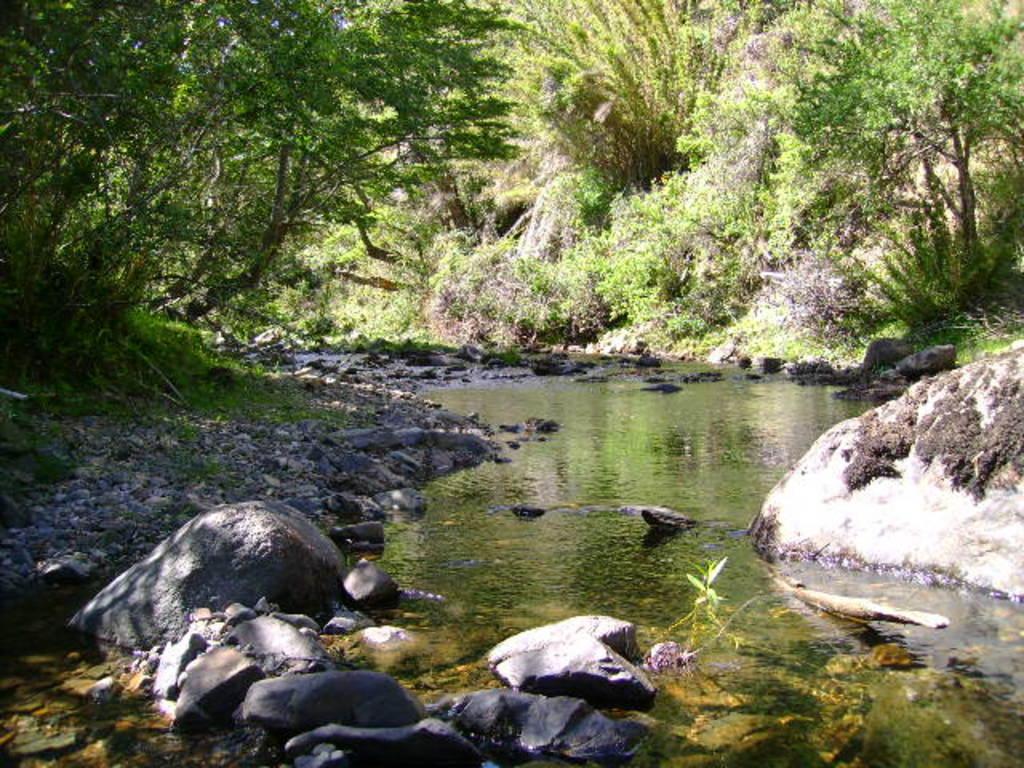How would you summarize this image in a sentence or two? Here we can see stones and water. Background we can see trees. 